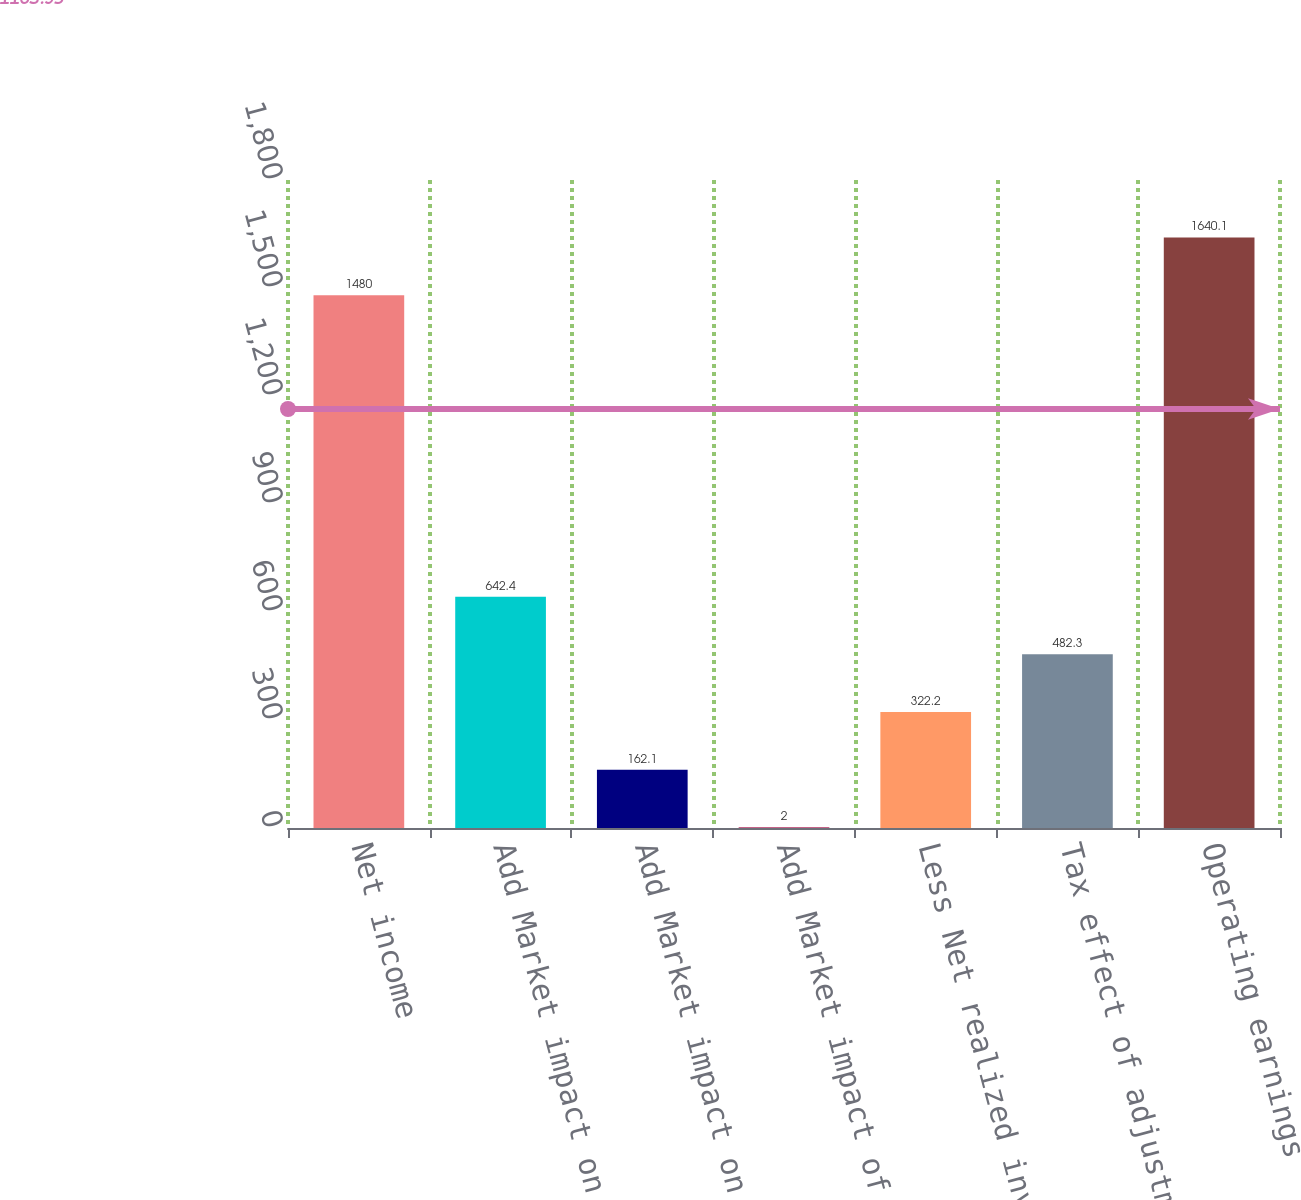Convert chart. <chart><loc_0><loc_0><loc_500><loc_500><bar_chart><fcel>Net income<fcel>Add Market impact on variable<fcel>Add Market impact on indexed<fcel>Add Market impact of hedges on<fcel>Less Net realized investment<fcel>Tax effect of adjustments (2)<fcel>Operating earnings<nl><fcel>1480<fcel>642.4<fcel>162.1<fcel>2<fcel>322.2<fcel>482.3<fcel>1640.1<nl></chart> 